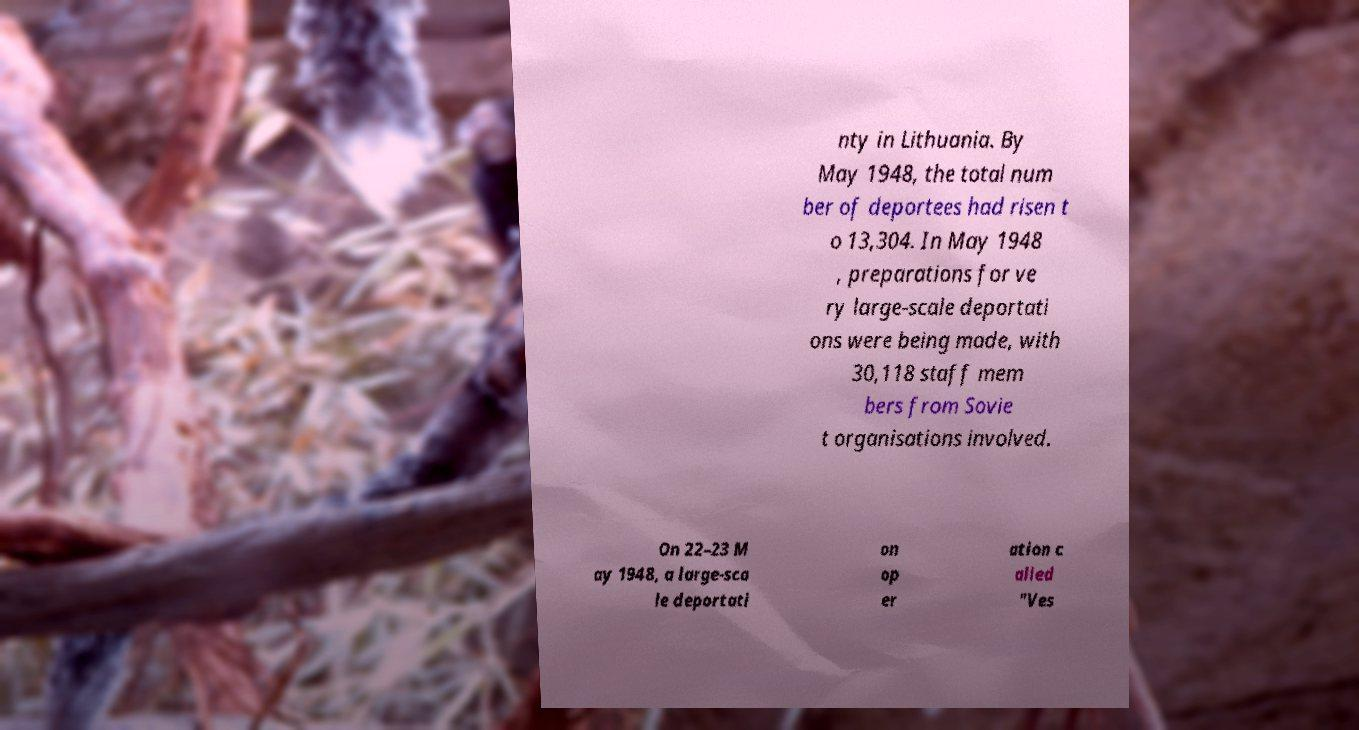For documentation purposes, I need the text within this image transcribed. Could you provide that? nty in Lithuania. By May 1948, the total num ber of deportees had risen t o 13,304. In May 1948 , preparations for ve ry large-scale deportati ons were being made, with 30,118 staff mem bers from Sovie t organisations involved. On 22–23 M ay 1948, a large-sca le deportati on op er ation c alled "Ves 